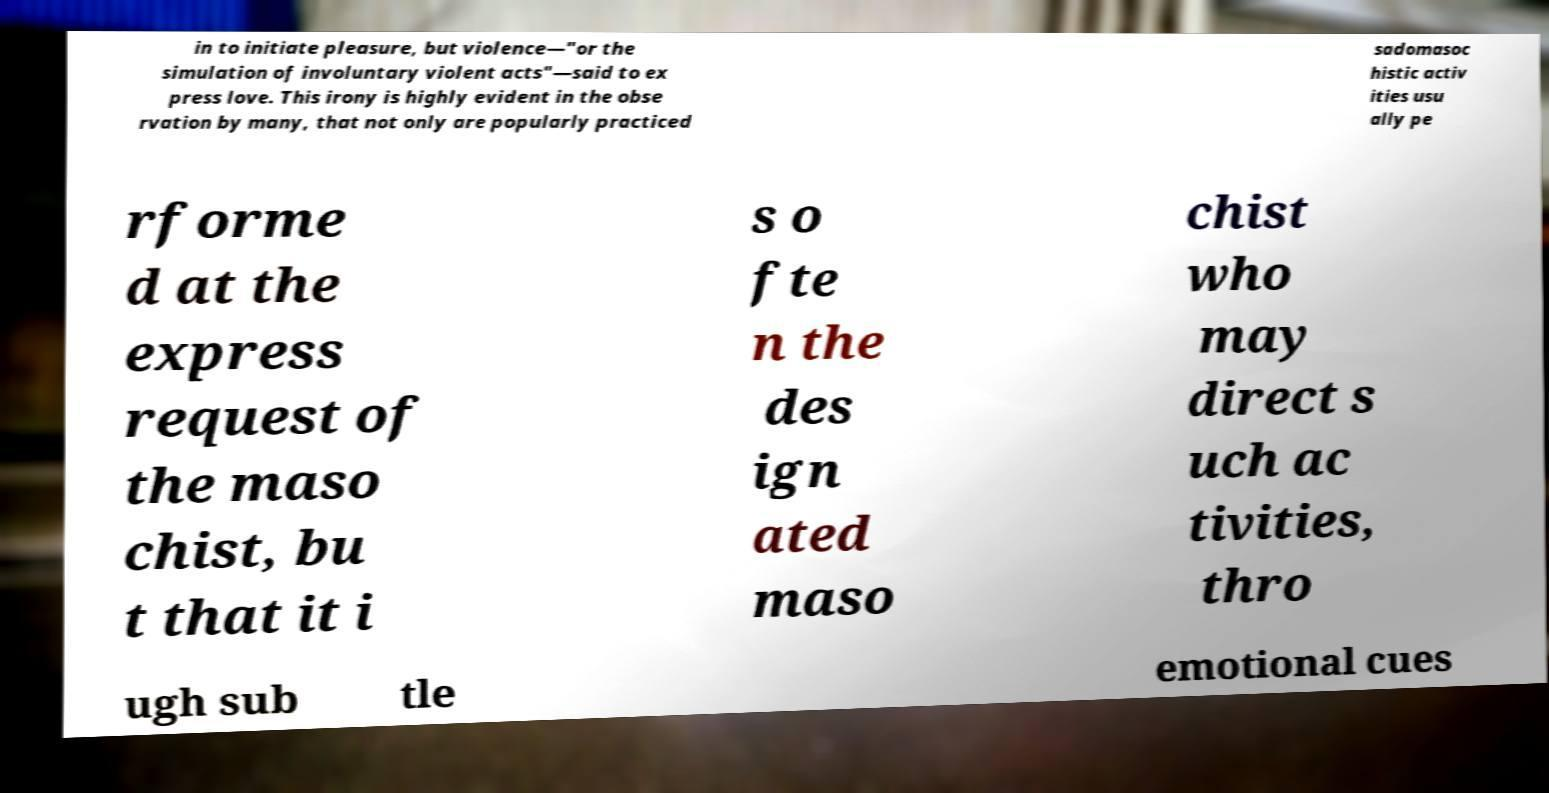I need the written content from this picture converted into text. Can you do that? in to initiate pleasure, but violence—"or the simulation of involuntary violent acts"—said to ex press love. This irony is highly evident in the obse rvation by many, that not only are popularly practiced sadomasoc histic activ ities usu ally pe rforme d at the express request of the maso chist, bu t that it i s o fte n the des ign ated maso chist who may direct s uch ac tivities, thro ugh sub tle emotional cues 